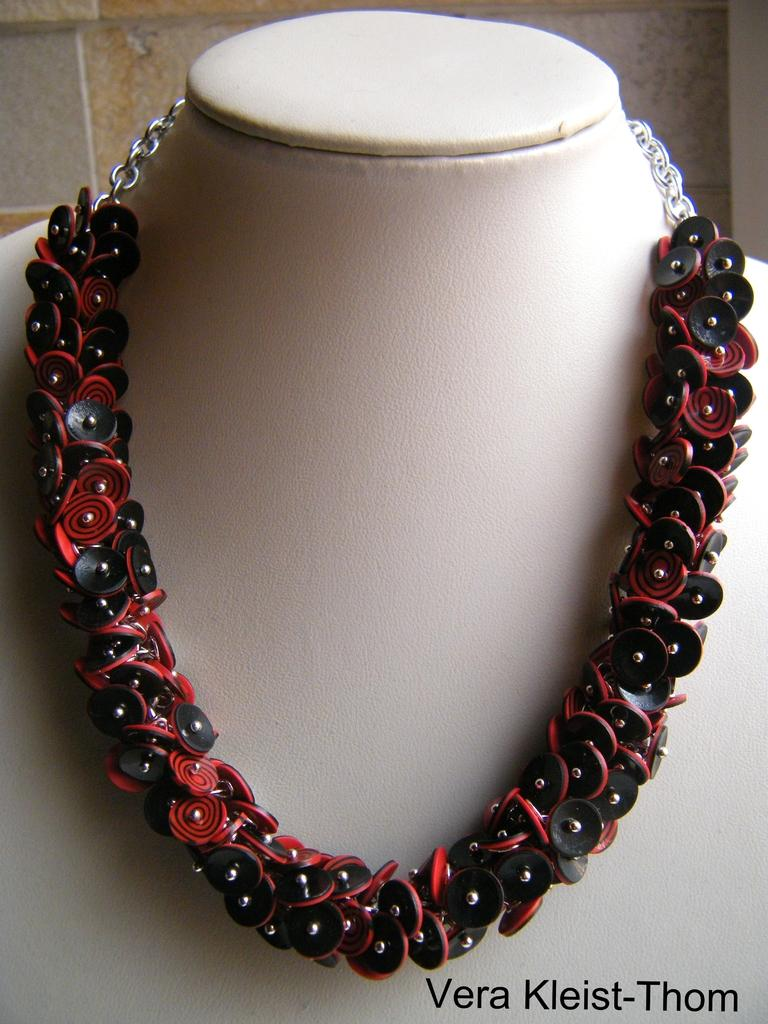What is the main subject in the center of the image? There is a necklace in the center of the image. What is the necklace placed on? The necklace is on a white color object. What colors are present in the necklace? The necklace has a mixed color of black and red. What can be seen in the background of the image? There is a wall in the background of the image. What type of tin is being used to store the necklace in the image? There is no tin present in the image; the necklace is placed on a white color object. What advice does the mom give about the necklace in the image? There is no mention of a mom or any advice in the image; it only shows a necklace on a white color object. 